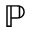<formula> <loc_0><loc_0><loc_500><loc_500>\mathbb { P }</formula> 